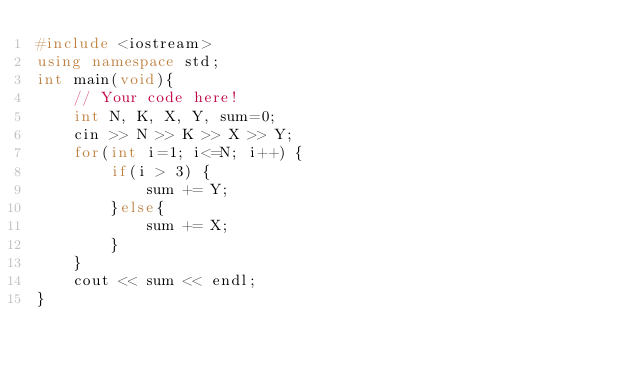Convert code to text. <code><loc_0><loc_0><loc_500><loc_500><_C++_>#include <iostream>
using namespace std;
int main(void){
    // Your code here!
    int N, K, X, Y, sum=0;
    cin >> N >> K >> X >> Y;
    for(int i=1; i<=N; i++) {
        if(i > 3) {
            sum += Y;
        }else{
            sum += X;
        }
    }
    cout << sum << endl;
}
</code> 